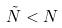Convert formula to latex. <formula><loc_0><loc_0><loc_500><loc_500>\tilde { N } < N</formula> 